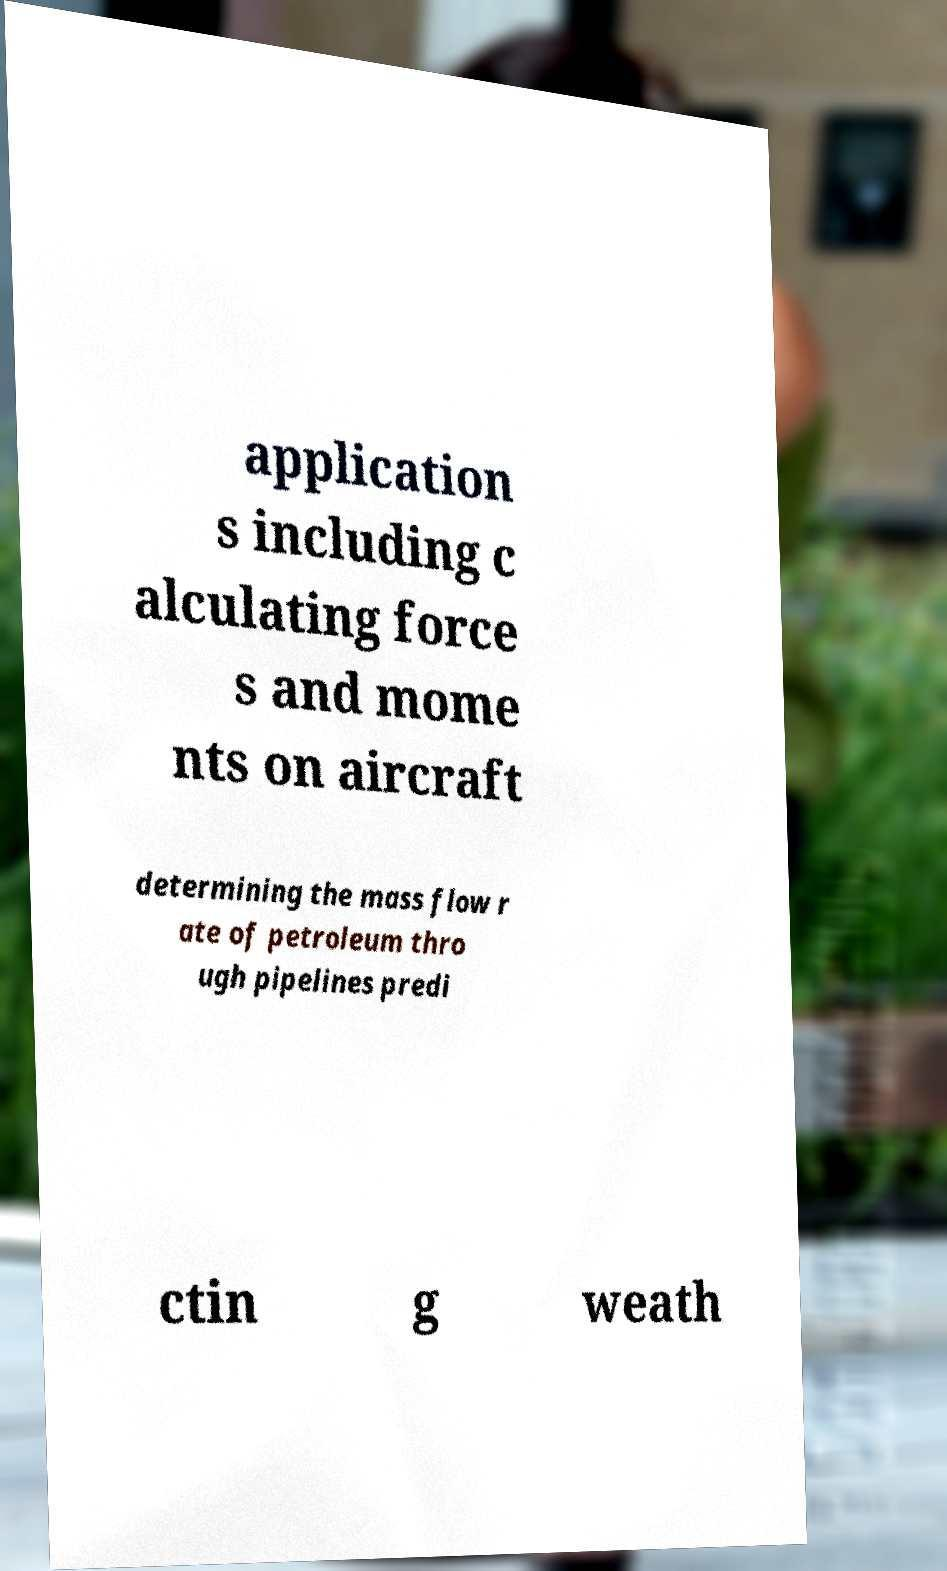Could you assist in decoding the text presented in this image and type it out clearly? application s including c alculating force s and mome nts on aircraft determining the mass flow r ate of petroleum thro ugh pipelines predi ctin g weath 